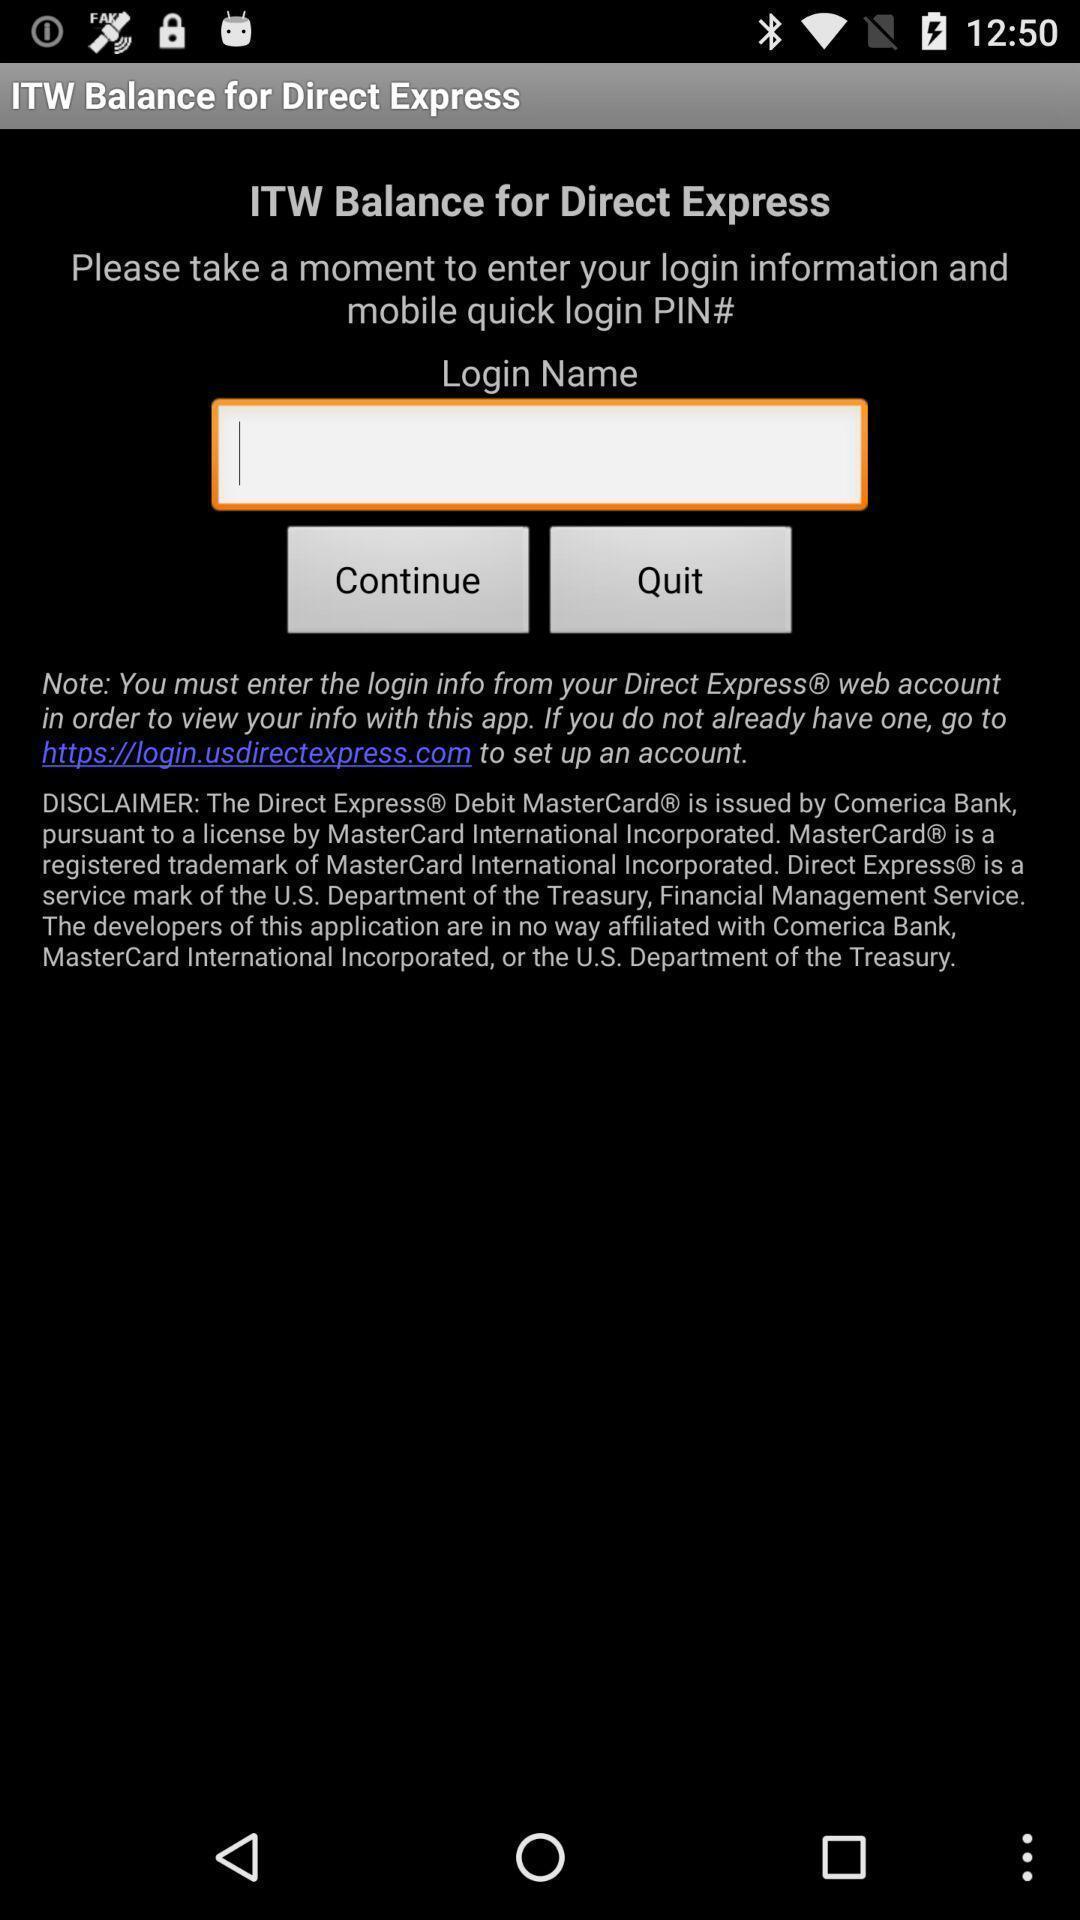Please provide a description for this image. Screen displaying login name option. 